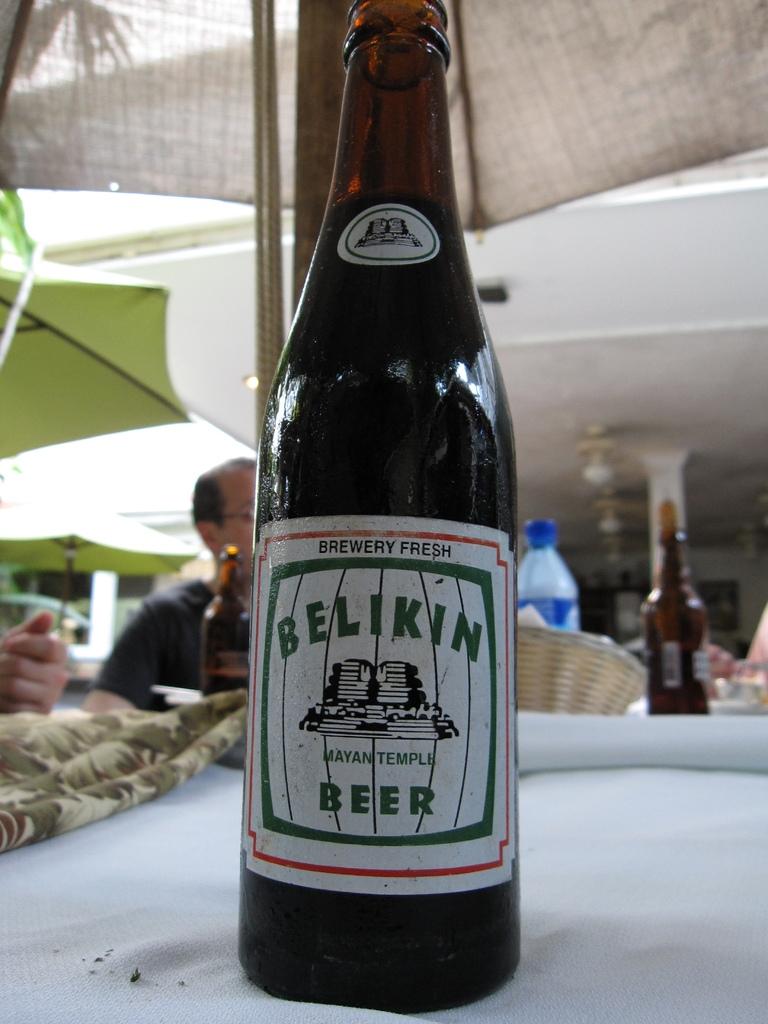What is the name of the beer?
Provide a short and direct response. Belikin. What is at the top of the label?
Your answer should be compact. Brewery fresh. 